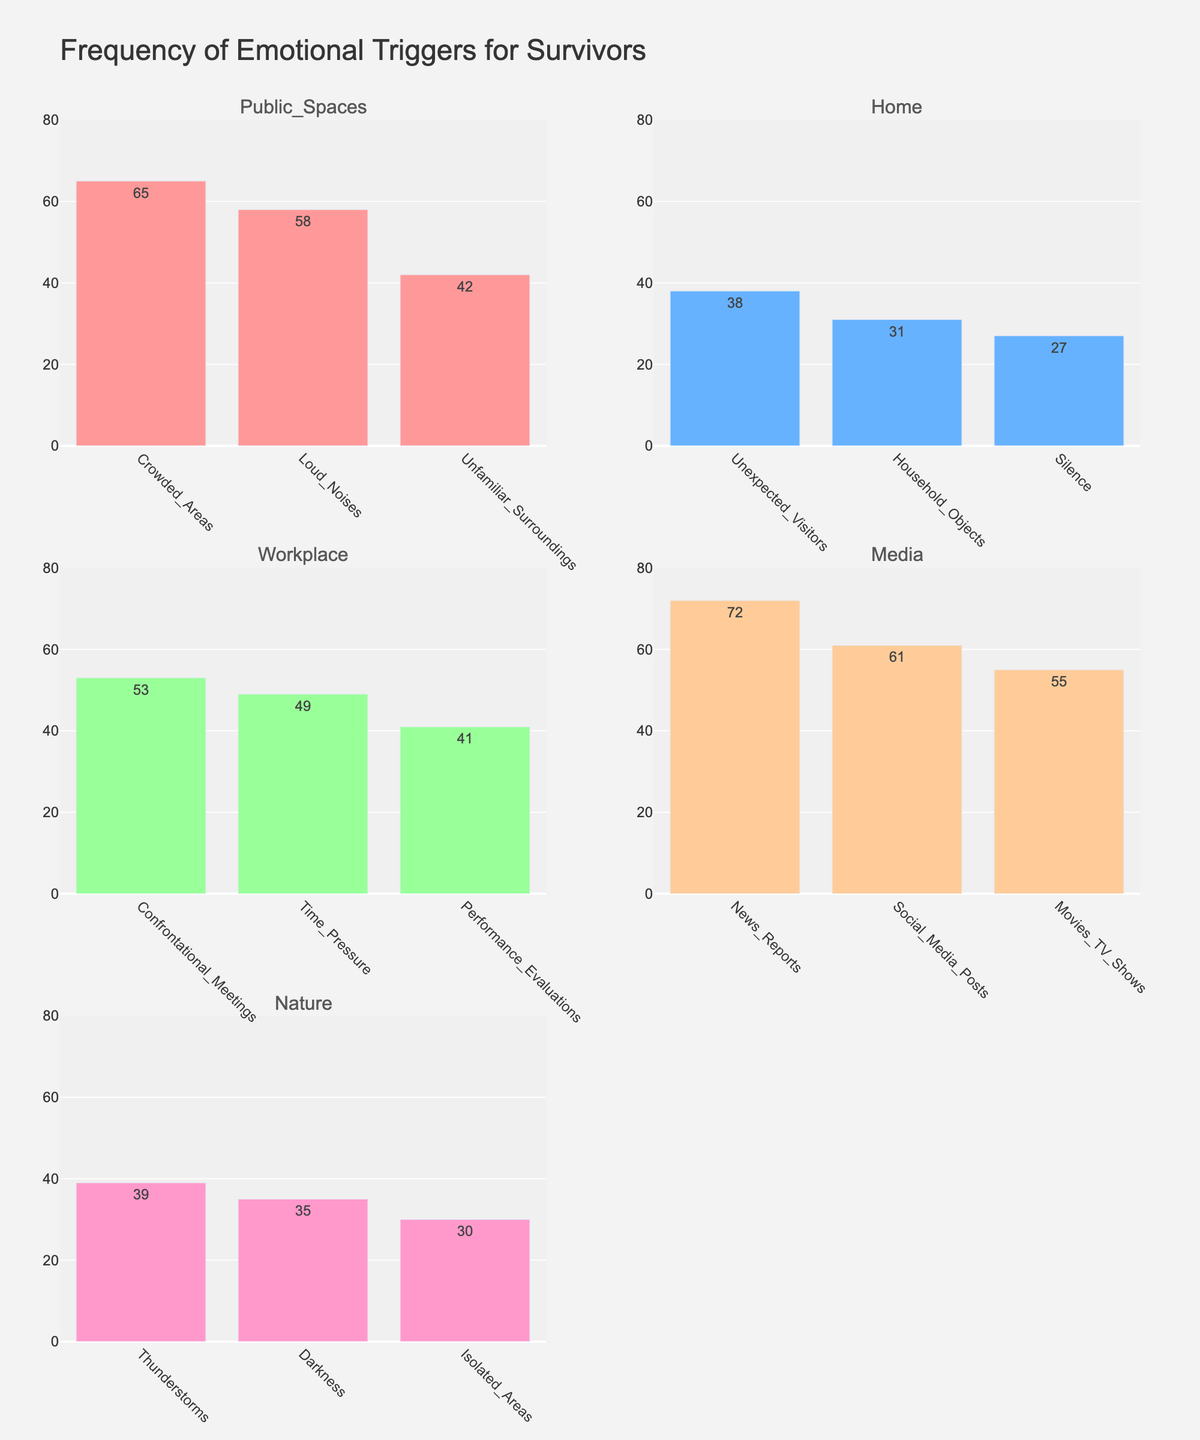What's the most frequent emotional trigger in public spaces? The chart displays bars for different triggers in public spaces. The tallest bar represents 'Crowded Areas' with a frequency of 65.
Answer: Crowded Areas Which environmental factor has the highest reported frequency for an emotional trigger? The reported frequencies across different environmental factors are shown in their respective subplots. 'Media' has the highest reported trigger, 'News Reports' with a frequency of 72.
Answer: Media Compare the frequency of 'Time Pressure' in the workplace with 'Unexpected Visitors' at home. Which one is higher? The bar for 'Time Pressure' in the workplace shows a frequency of 49, and the bar for 'Unexpected Visitors' at home shows a frequency of 38. Since 49 > 38, 'Time Pressure' is higher.
Answer: Time Pressure Among the triggers listed under media, which one has the lowest frequency? The chart under the media category includes 'News Reports' (72), 'Social Media Posts' (61), and 'Movies & TV Shows' (55). The lowest frequency among these is 'Movies & TV Shows' with a frequency of 55.
Answer: Movies & TV Shows What's the combined frequency of all triggers in nature? The frequencies for nature are 'Thunderstorms' (39), 'Darkness' (35), and 'Isolated Areas' (30). Adding them: 39 + 35 + 30 = 104.
Answer: 104 In which environment factor does 'Silence' appear, and how frequently does it occur? The chart associated with home shows 'Silence' with a frequency of 27.
Answer: Home, 27 Calculate the average frequency of triggers in the workplace. The frequencies in the workplace are 'Confrontational Meetings' (53), 'Time Pressure' (49), and 'Performance Evaluations' (41). Summing these gives: 53 + 49 + 41 = 143. Dividing by the number of triggers: 143/3 ≈ 47.67.
Answer: 47.67 Are there any triggers with a frequency exactly equal to 30? If yes, name the triggers and their respective environmental factors. The chart shows 'Household Objects' at home (31), 'Isolated Areas' in nature (30), and all other frequencies are different. 'Isolated Areas' in nature has exactly 30.
Answer: Isolated Areas, nature Which environment factor has the smallest range of reported frequencies for its triggers? Calculating the range involves finding the difference between the highest and lowest frequencies in each category. At home: 38-27=11. Nature: 39-30=9. Public spaces: 65-42=23. Workplace: 53-41=12. Media: 72-55=17. The smallest range is in nature with 9.
Answer: Nature 